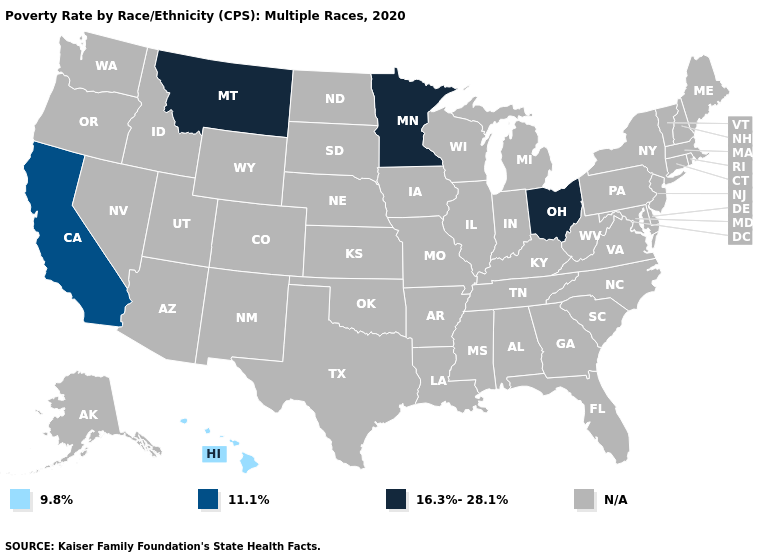Which states have the lowest value in the MidWest?
Quick response, please. Minnesota, Ohio. Does the map have missing data?
Write a very short answer. Yes. Name the states that have a value in the range 16.3%-28.1%?
Answer briefly. Minnesota, Montana, Ohio. Does Montana have the highest value in the West?
Give a very brief answer. Yes. Which states have the highest value in the USA?
Give a very brief answer. Minnesota, Montana, Ohio. What is the value of Vermont?
Keep it brief. N/A. Name the states that have a value in the range 11.1%?
Quick response, please. California. What is the value of Delaware?
Quick response, please. N/A. What is the lowest value in states that border Iowa?
Write a very short answer. 16.3%-28.1%. What is the lowest value in the USA?
Give a very brief answer. 9.8%. 